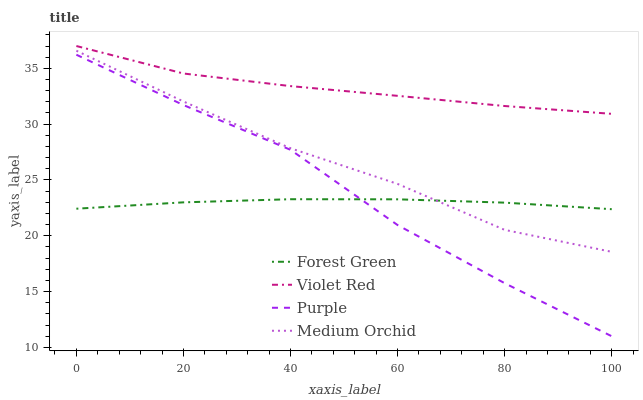Does Forest Green have the minimum area under the curve?
Answer yes or no. Yes. Does Violet Red have the maximum area under the curve?
Answer yes or no. Yes. Does Medium Orchid have the minimum area under the curve?
Answer yes or no. No. Does Medium Orchid have the maximum area under the curve?
Answer yes or no. No. Is Forest Green the smoothest?
Answer yes or no. Yes. Is Purple the roughest?
Answer yes or no. Yes. Is Medium Orchid the smoothest?
Answer yes or no. No. Is Medium Orchid the roughest?
Answer yes or no. No. Does Forest Green have the lowest value?
Answer yes or no. No. Does Violet Red have the highest value?
Answer yes or no. Yes. Does Medium Orchid have the highest value?
Answer yes or no. No. Is Purple less than Violet Red?
Answer yes or no. Yes. Is Violet Red greater than Purple?
Answer yes or no. Yes. Does Forest Green intersect Medium Orchid?
Answer yes or no. Yes. Is Forest Green less than Medium Orchid?
Answer yes or no. No. Is Forest Green greater than Medium Orchid?
Answer yes or no. No. Does Purple intersect Violet Red?
Answer yes or no. No. 